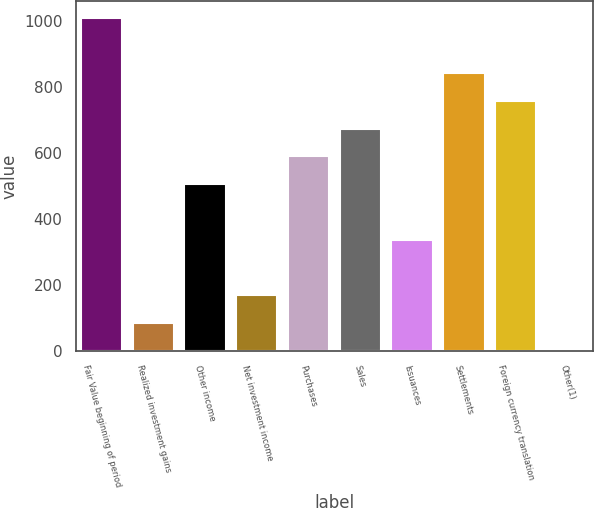<chart> <loc_0><loc_0><loc_500><loc_500><bar_chart><fcel>Fair Value beginning of period<fcel>Realized investment gains<fcel>Other income<fcel>Net investment income<fcel>Purchases<fcel>Sales<fcel>Issuances<fcel>Settlements<fcel>Foreign currency translation<fcel>Other(1)<nl><fcel>1010.29<fcel>84.53<fcel>505.33<fcel>168.69<fcel>589.49<fcel>673.65<fcel>337.01<fcel>841.97<fcel>757.81<fcel>0.37<nl></chart> 